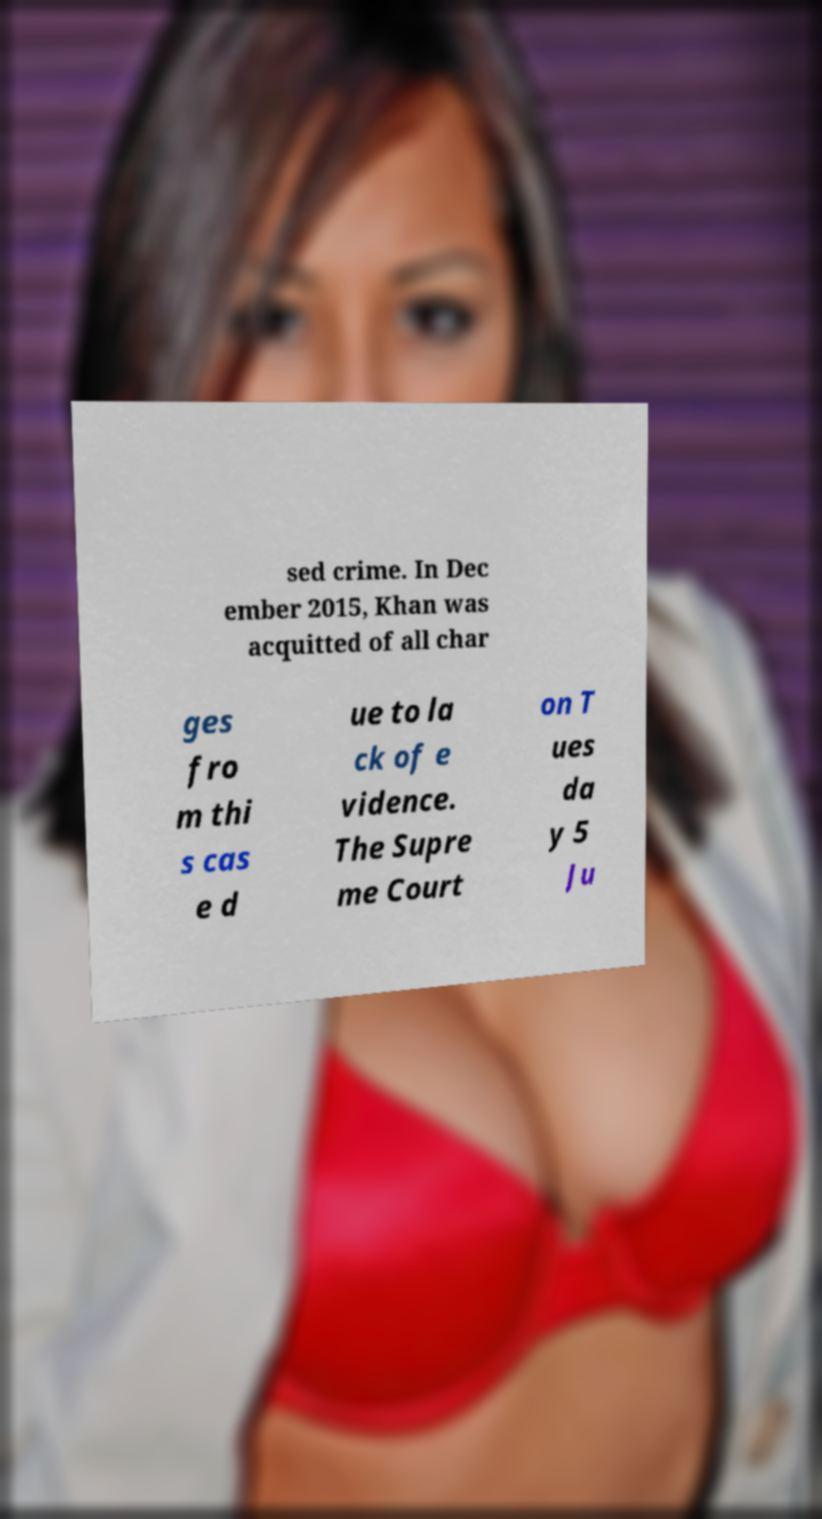There's text embedded in this image that I need extracted. Can you transcribe it verbatim? sed crime. In Dec ember 2015, Khan was acquitted of all char ges fro m thi s cas e d ue to la ck of e vidence. The Supre me Court on T ues da y 5 Ju 